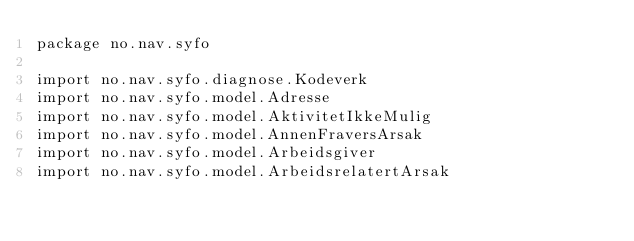<code> <loc_0><loc_0><loc_500><loc_500><_Kotlin_>package no.nav.syfo

import no.nav.syfo.diagnose.Kodeverk
import no.nav.syfo.model.Adresse
import no.nav.syfo.model.AktivitetIkkeMulig
import no.nav.syfo.model.AnnenFraversArsak
import no.nav.syfo.model.Arbeidsgiver
import no.nav.syfo.model.ArbeidsrelatertArsak</code> 